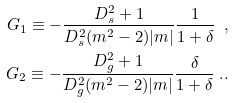Convert formula to latex. <formula><loc_0><loc_0><loc_500><loc_500>G _ { 1 } \equiv - \frac { D _ { s } ^ { 2 } + 1 } { D _ { s } ^ { 2 } ( m ^ { 2 } - 2 ) | m | } \frac { 1 } { 1 + \delta } \ , \\ G _ { 2 } \equiv - \frac { D _ { g } ^ { 2 } + 1 } { D _ { g } ^ { 2 } ( m ^ { 2 } - 2 ) | m | } \frac { \delta } { 1 + \delta } \ . .</formula> 